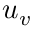Convert formula to latex. <formula><loc_0><loc_0><loc_500><loc_500>u _ { v }</formula> 